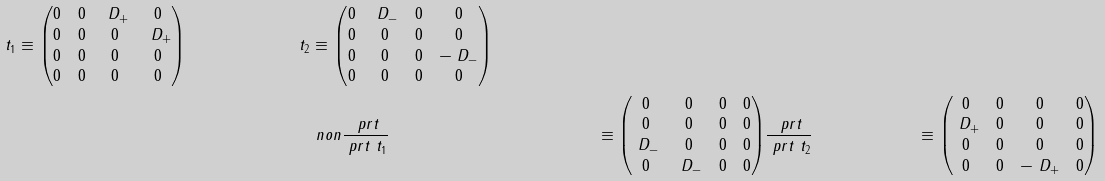<formula> <loc_0><loc_0><loc_500><loc_500>\ t _ { 1 } & \equiv \begin{pmatrix} 0 & 0 & \ D _ { + } & 0 \\ 0 & 0 & 0 & \ D _ { + } \\ 0 & 0 & 0 & 0 \\ 0 & 0 & 0 & 0 \end{pmatrix} & \ t _ { 2 } & \equiv \begin{pmatrix} 0 & \ D _ { - } & 0 & 0 \\ 0 & 0 & 0 & 0 \\ 0 & 0 & 0 & - \ D _ { - } \\ 0 & 0 & 0 & 0 \end{pmatrix} \\ & & & \ n o n \frac { \ p r t } { \ p r t \ t _ { 1 } } & \equiv \begin{pmatrix} 0 & 0 & 0 & 0 \\ 0 & 0 & 0 & 0 \\ \ D _ { - } & 0 & 0 & 0 \\ 0 & \ D _ { - } & 0 & 0 \end{pmatrix} & \frac { \ p r t } { \ p r t \ t _ { 2 } } & \equiv \begin{pmatrix} 0 & 0 & 0 & 0 \\ \ D _ { + } & 0 & 0 & 0 \\ 0 & 0 & 0 & 0 \\ 0 & 0 & - \ D _ { + } & 0 \end{pmatrix}</formula> 